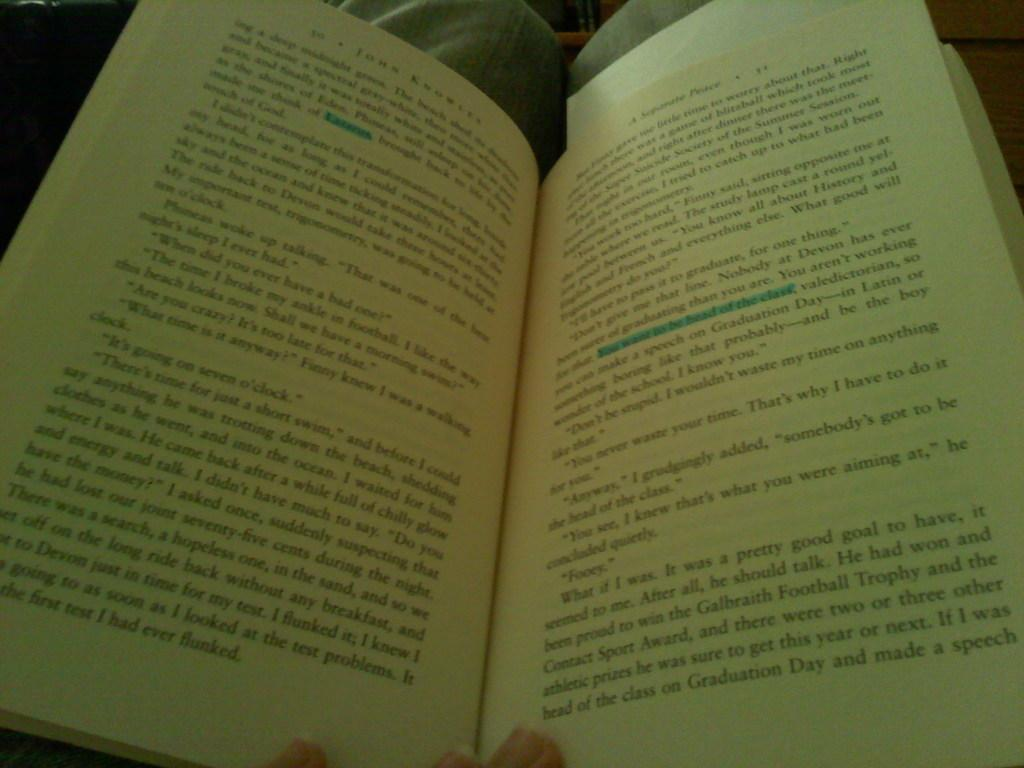<image>
Share a concise interpretation of the image provided. A person is reading page 31 of a book with a blue highlighter drawn in it. 